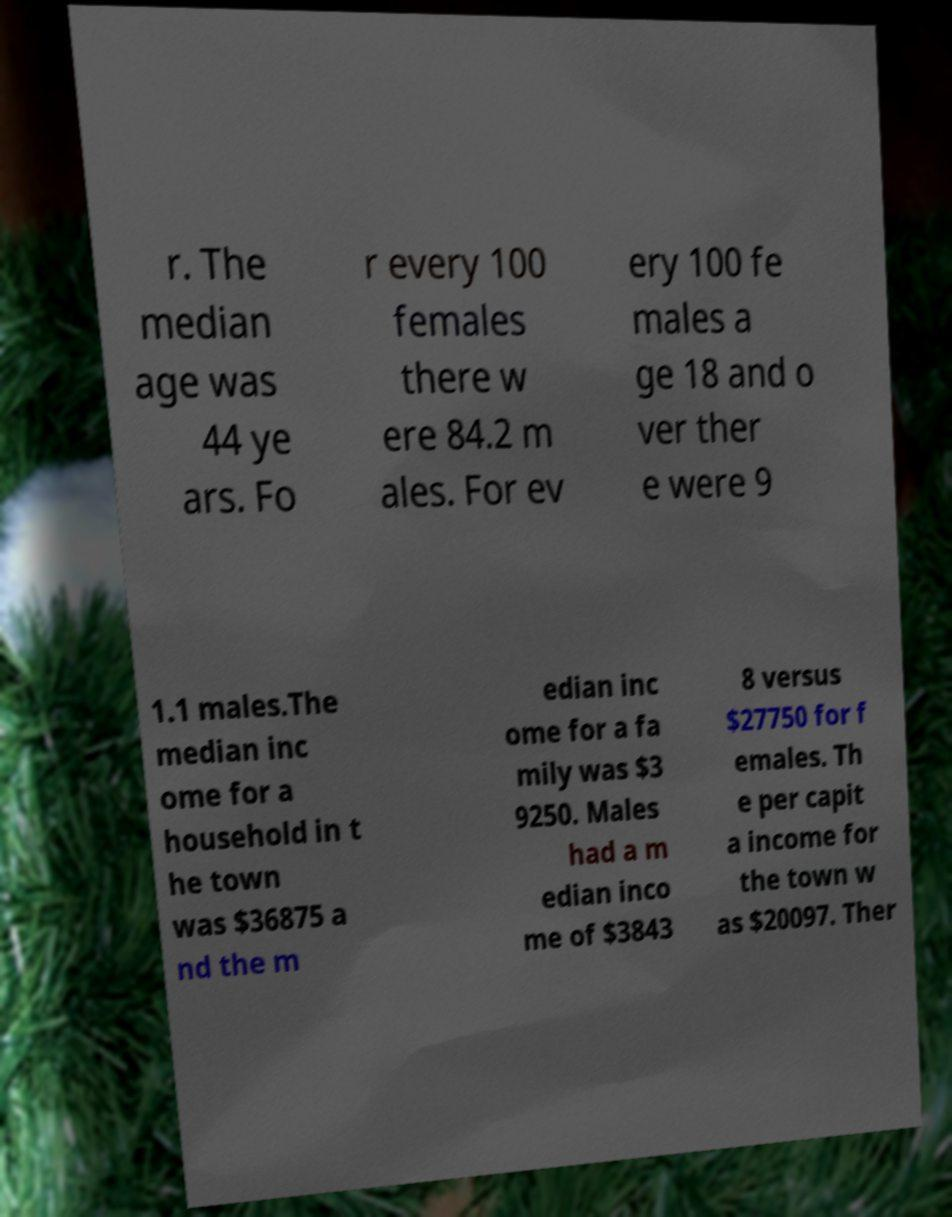Can you accurately transcribe the text from the provided image for me? r. The median age was 44 ye ars. Fo r every 100 females there w ere 84.2 m ales. For ev ery 100 fe males a ge 18 and o ver ther e were 9 1.1 males.The median inc ome for a household in t he town was $36875 a nd the m edian inc ome for a fa mily was $3 9250. Males had a m edian inco me of $3843 8 versus $27750 for f emales. Th e per capit a income for the town w as $20097. Ther 